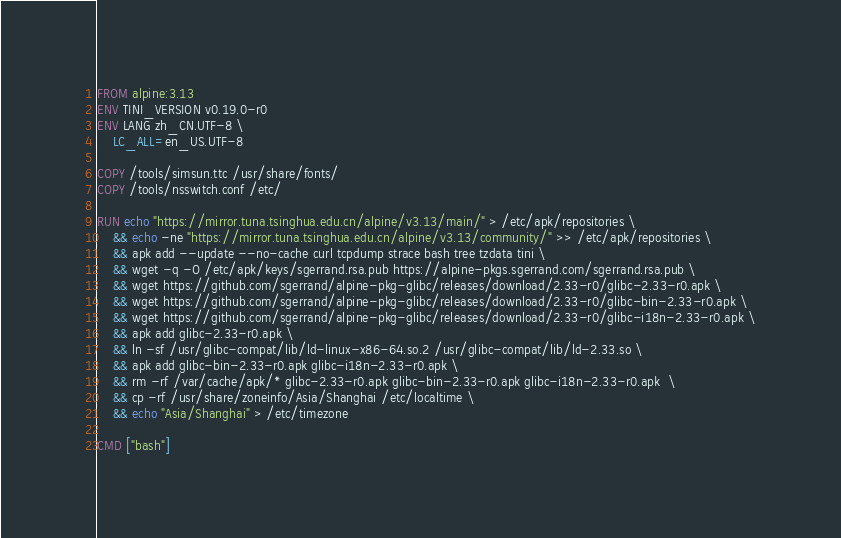<code> <loc_0><loc_0><loc_500><loc_500><_Dockerfile_>FROM alpine:3.13
ENV TINI_VERSION v0.19.0-r0
ENV LANG zh_CN.UTF-8 \
    LC_ALL=en_US.UTF-8

COPY /tools/simsun.ttc /usr/share/fonts/
COPY /tools/nsswitch.conf /etc/

RUN echo "https://mirror.tuna.tsinghua.edu.cn/alpine/v3.13/main/" > /etc/apk/repositories \
    && echo -ne "https://mirror.tuna.tsinghua.edu.cn/alpine/v3.13/community/" >> /etc/apk/repositories \
    && apk add --update --no-cache curl tcpdump strace bash tree tzdata tini \
    && wget -q -O /etc/apk/keys/sgerrand.rsa.pub https://alpine-pkgs.sgerrand.com/sgerrand.rsa.pub \
    && wget https://github.com/sgerrand/alpine-pkg-glibc/releases/download/2.33-r0/glibc-2.33-r0.apk \
    && wget https://github.com/sgerrand/alpine-pkg-glibc/releases/download/2.33-r0/glibc-bin-2.33-r0.apk \
    && wget https://github.com/sgerrand/alpine-pkg-glibc/releases/download/2.33-r0/glibc-i18n-2.33-r0.apk \
    && apk add glibc-2.33-r0.apk \
    && ln -sf /usr/glibc-compat/lib/ld-linux-x86-64.so.2 /usr/glibc-compat/lib/ld-2.33.so \
    && apk add glibc-bin-2.33-r0.apk glibc-i18n-2.33-r0.apk \
    && rm -rf /var/cache/apk/* glibc-2.33-r0.apk glibc-bin-2.33-r0.apk glibc-i18n-2.33-r0.apk  \
    && cp -rf /usr/share/zoneinfo/Asia/Shanghai /etc/localtime \
    && echo "Asia/Shanghai" > /etc/timezone

CMD ["bash"]</code> 